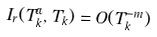Convert formula to latex. <formula><loc_0><loc_0><loc_500><loc_500>I _ { r } ( T _ { k } ^ { \alpha } , T _ { k } ) = O ( T _ { k } ^ { - m } )</formula> 